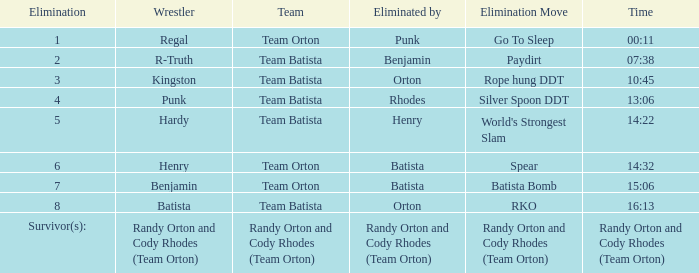Which Wrestler plays for Team Batista which was Elimated by Orton on Elimination 8? Batista. 